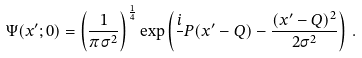<formula> <loc_0><loc_0><loc_500><loc_500>\Psi ( x ^ { \prime } ; 0 ) = \left ( \frac { 1 } { \pi \sigma ^ { 2 } } \right ) ^ { \frac { 1 } { 4 } } \exp \left ( \frac { i } { } P ( x ^ { \prime } - Q ) - \frac { ( x ^ { \prime } - Q ) ^ { 2 } } { 2 \sigma ^ { 2 } } \right ) \, .</formula> 